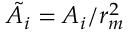<formula> <loc_0><loc_0><loc_500><loc_500>\tilde { A _ { i } } = A _ { i } / r _ { m } ^ { 2 }</formula> 